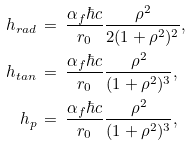Convert formula to latex. <formula><loc_0><loc_0><loc_500><loc_500>h _ { r a d } \, & = \, \frac { \alpha _ { f } \hbar { c } } { r _ { 0 } } \frac { \rho ^ { 2 } } { 2 ( 1 + \rho ^ { 2 } ) ^ { 2 } } , \\ h _ { t a n } \, & = \, \frac { \alpha _ { f } \hbar { c } } { r _ { 0 } } \frac { \rho ^ { 2 } } { ( 1 + \rho ^ { 2 } ) ^ { 3 } } , \\ h _ { p } \, & = \, \frac { \alpha _ { f } \hbar { c } } { r _ { 0 } } \frac { \rho ^ { 2 } } { ( 1 + \rho ^ { 2 } ) ^ { 3 } } ,</formula> 